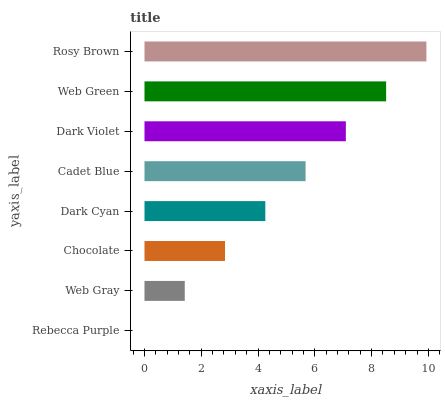Is Rebecca Purple the minimum?
Answer yes or no. Yes. Is Rosy Brown the maximum?
Answer yes or no. Yes. Is Web Gray the minimum?
Answer yes or no. No. Is Web Gray the maximum?
Answer yes or no. No. Is Web Gray greater than Rebecca Purple?
Answer yes or no. Yes. Is Rebecca Purple less than Web Gray?
Answer yes or no. Yes. Is Rebecca Purple greater than Web Gray?
Answer yes or no. No. Is Web Gray less than Rebecca Purple?
Answer yes or no. No. Is Cadet Blue the high median?
Answer yes or no. Yes. Is Dark Cyan the low median?
Answer yes or no. Yes. Is Rebecca Purple the high median?
Answer yes or no. No. Is Chocolate the low median?
Answer yes or no. No. 